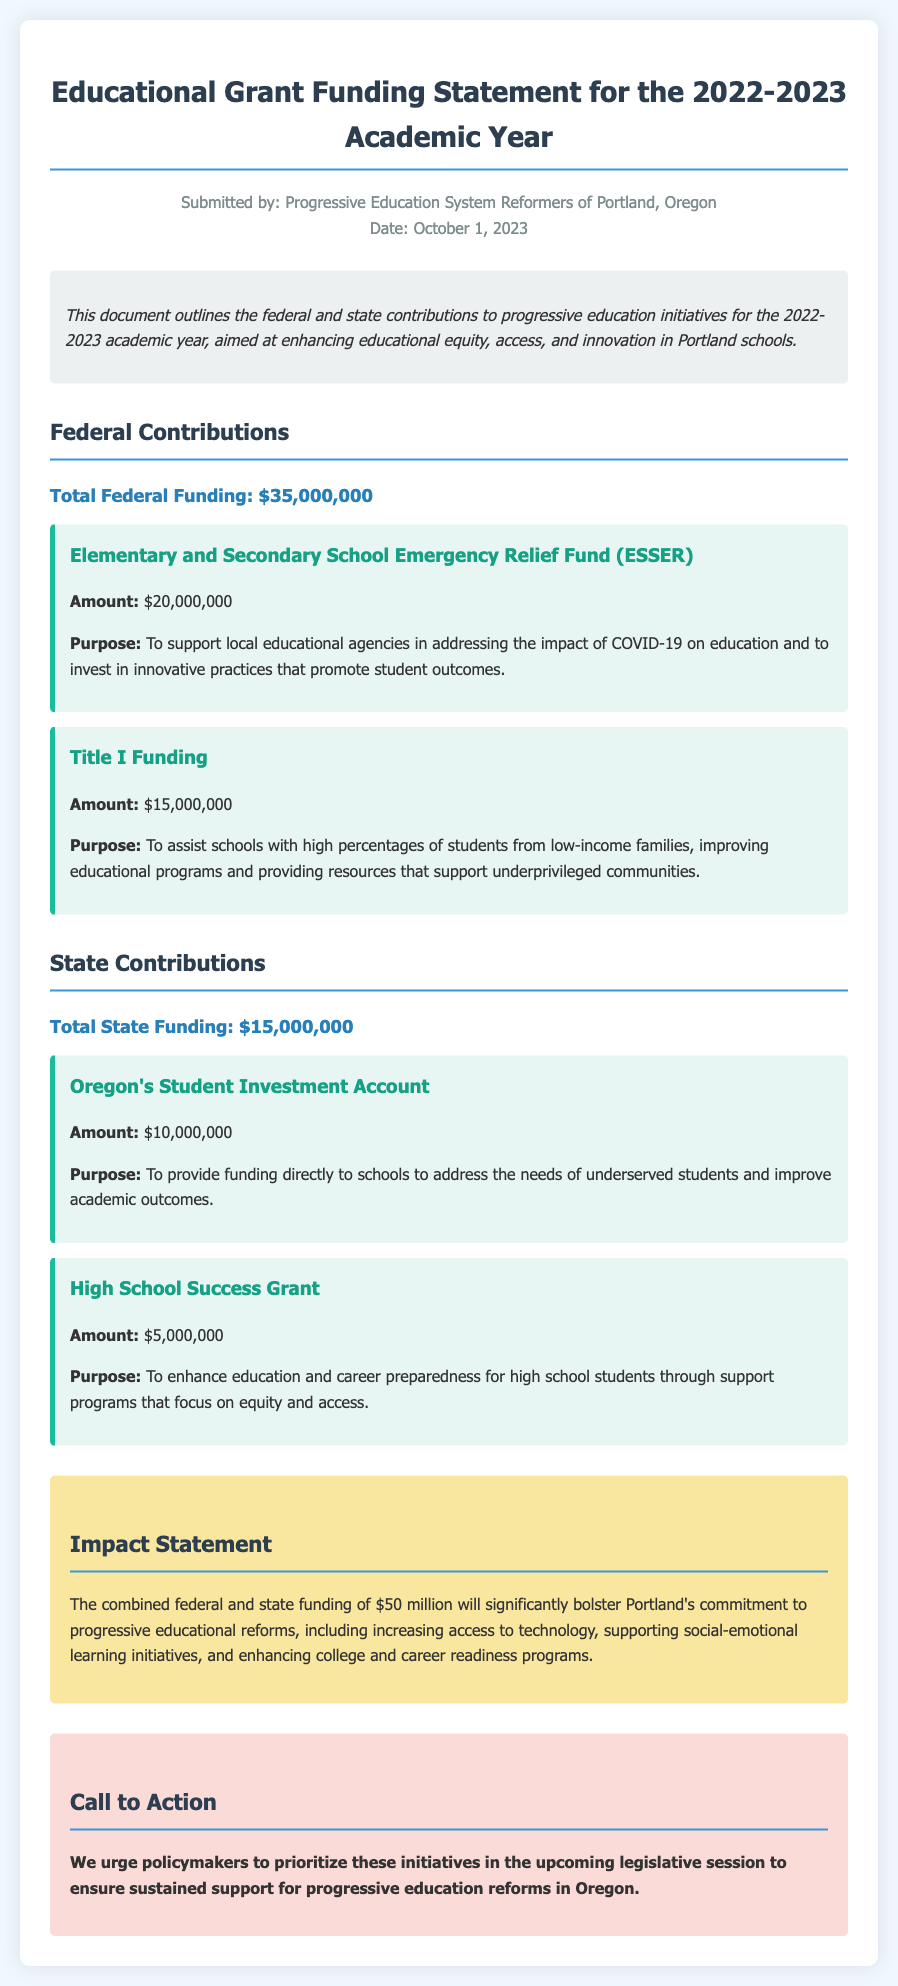What is the total federal funding? The total federal funding is stated in the document, which sums the federal contributions outlined.
Answer: $35,000,000 What is the purpose of the Title I Funding? The purpose of Title I Funding is detailed in the document as supporting schools with high percentages of students from low-income families.
Answer: To assist schools with high percentages of students from low-income families How much is allocated to the High School Success Grant? The amount allocated to the High School Success Grant is clearly marked in the funding section of the document.
Answer: $5,000,000 What is the combined total funding from both federal and state sources? The combined total funding is the sum of both federal and state contributions mentioned in the document.
Answer: $50,000,000 Who submitted the document? The document provides information on who submitted the educational grant funding statement.
Answer: Progressive Education System Reformers of Portland, Oregon What is the funding amount for Oregon's Student Investment Account? The funding amount for the Oregon's Student Investment Account is specified in the state contributions section.
Answer: $10,000,000 What is the main impact expected from the funding? The expected impact from the funding is summarized in the impact statement section of the document.
Answer: Bolster Portland's commitment to progressive educational reforms 